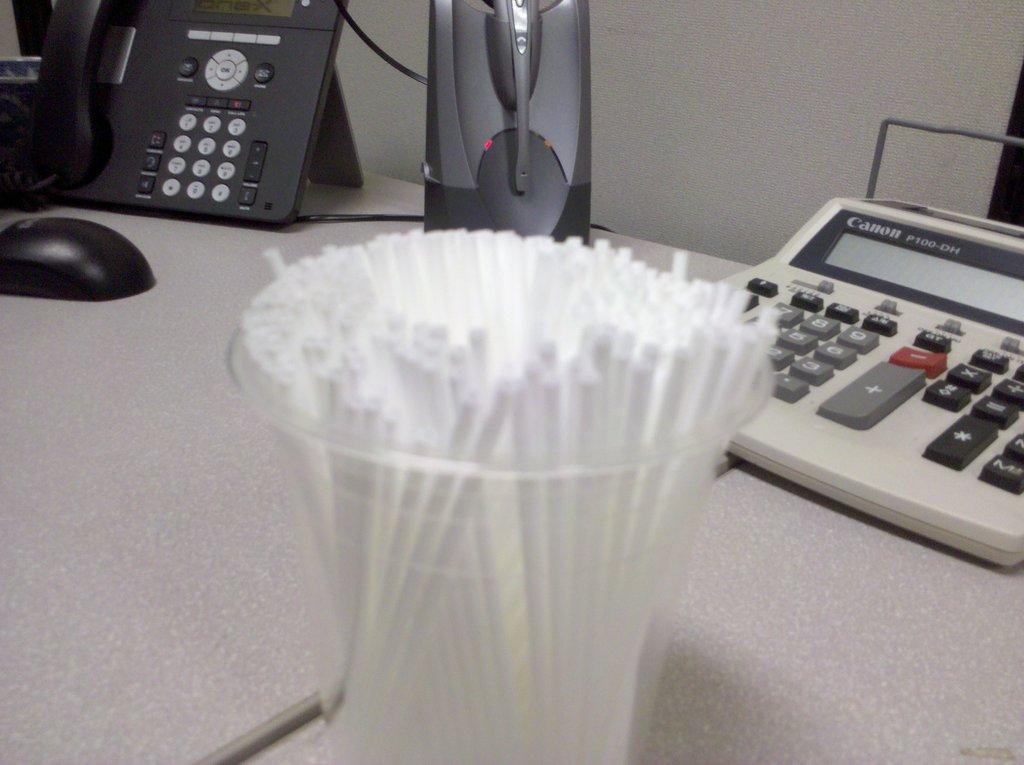<image>
Relay a brief, clear account of the picture shown. A Canon adding machine sitting on a white tabletop. 